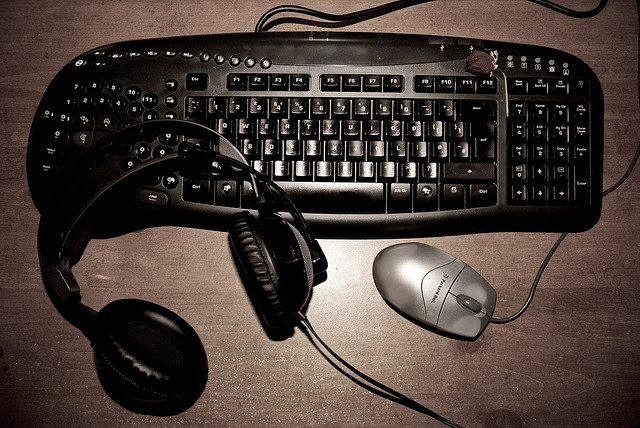Read and extract the text from this image. L U T 